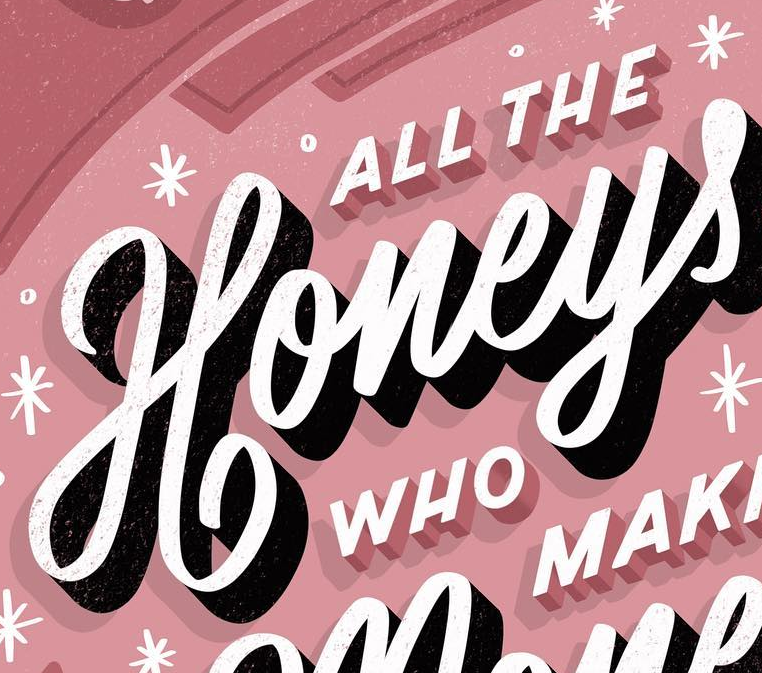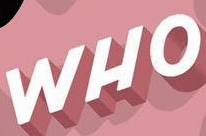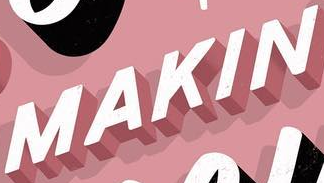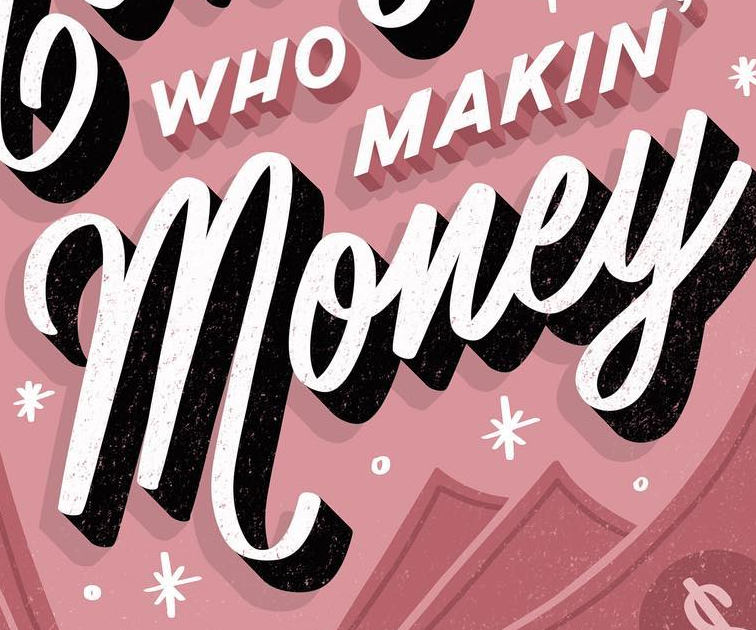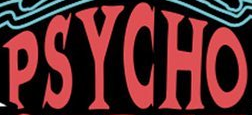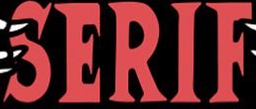What text appears in these images from left to right, separated by a semicolon? Honeys; WHO; MAKIN; money; PSYCHO; SERIF 